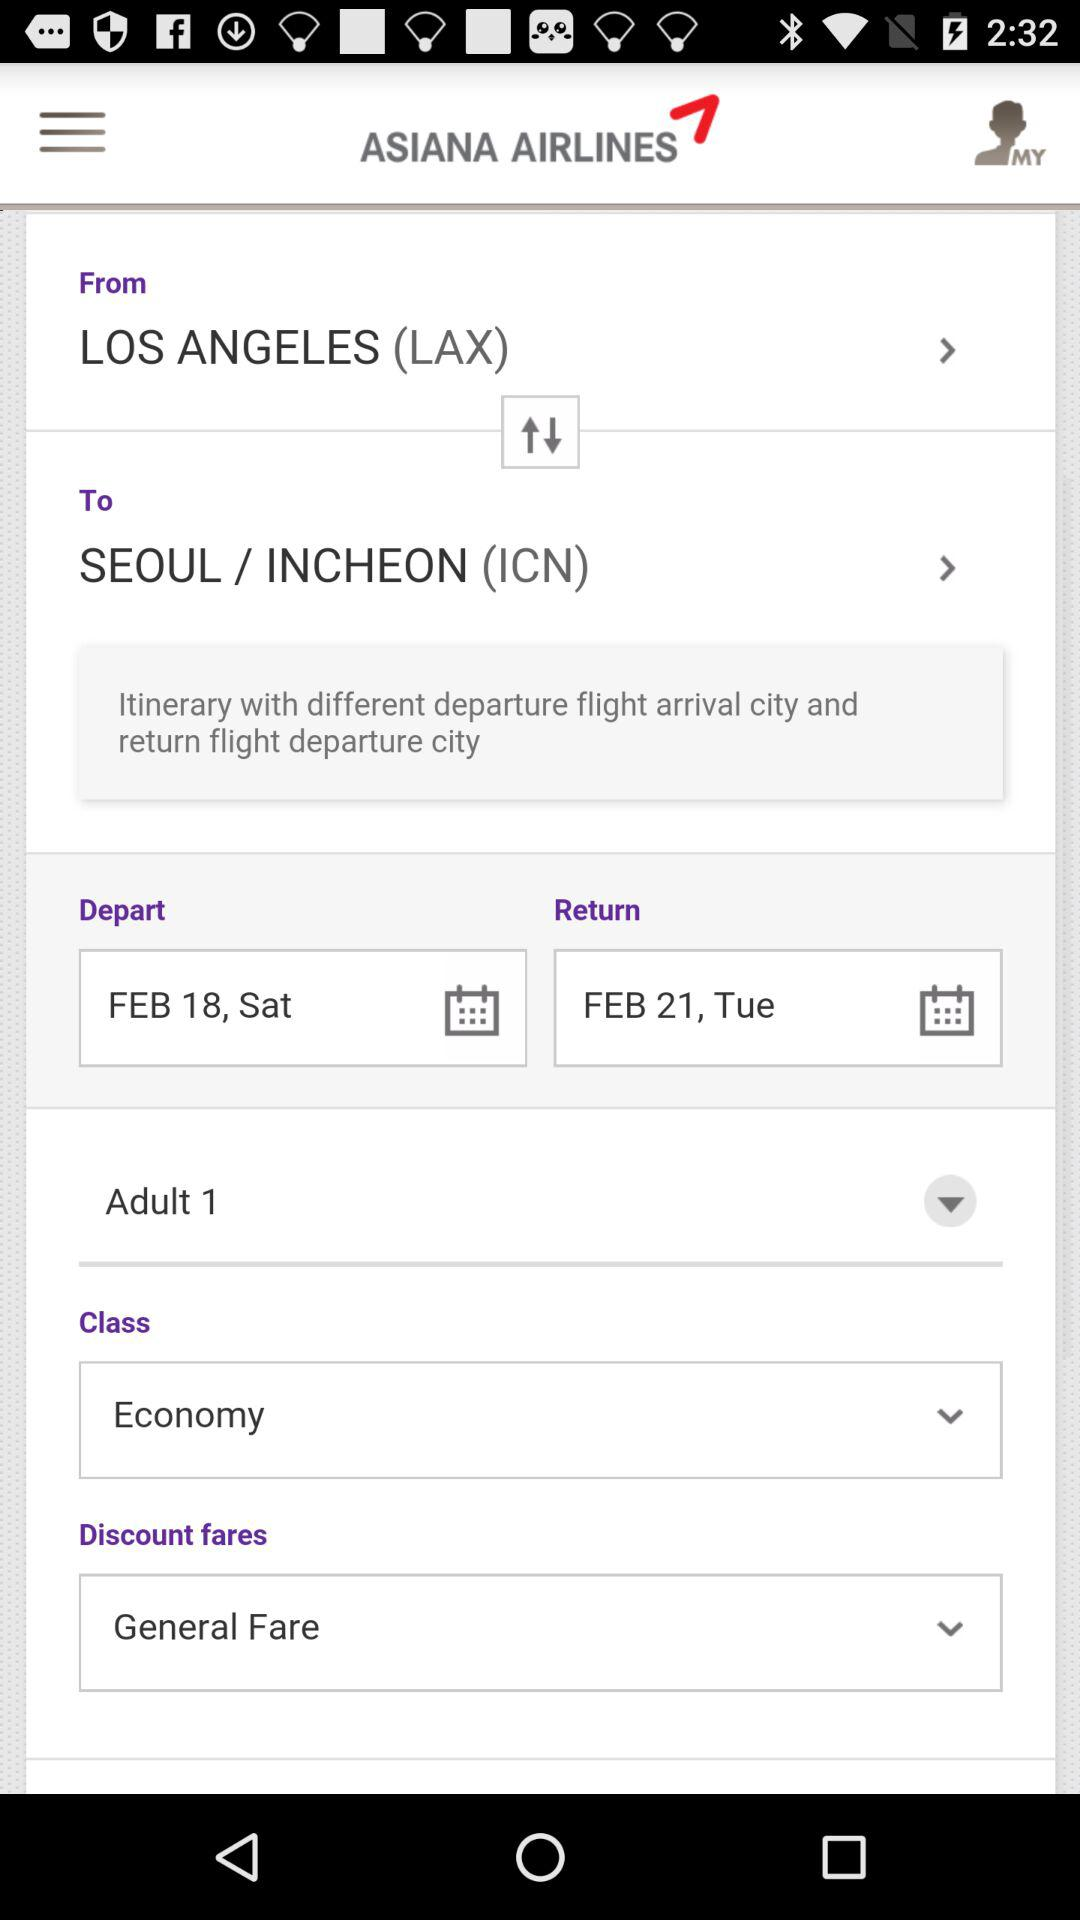What is the return date? The return date is February 21, Tuesday. 